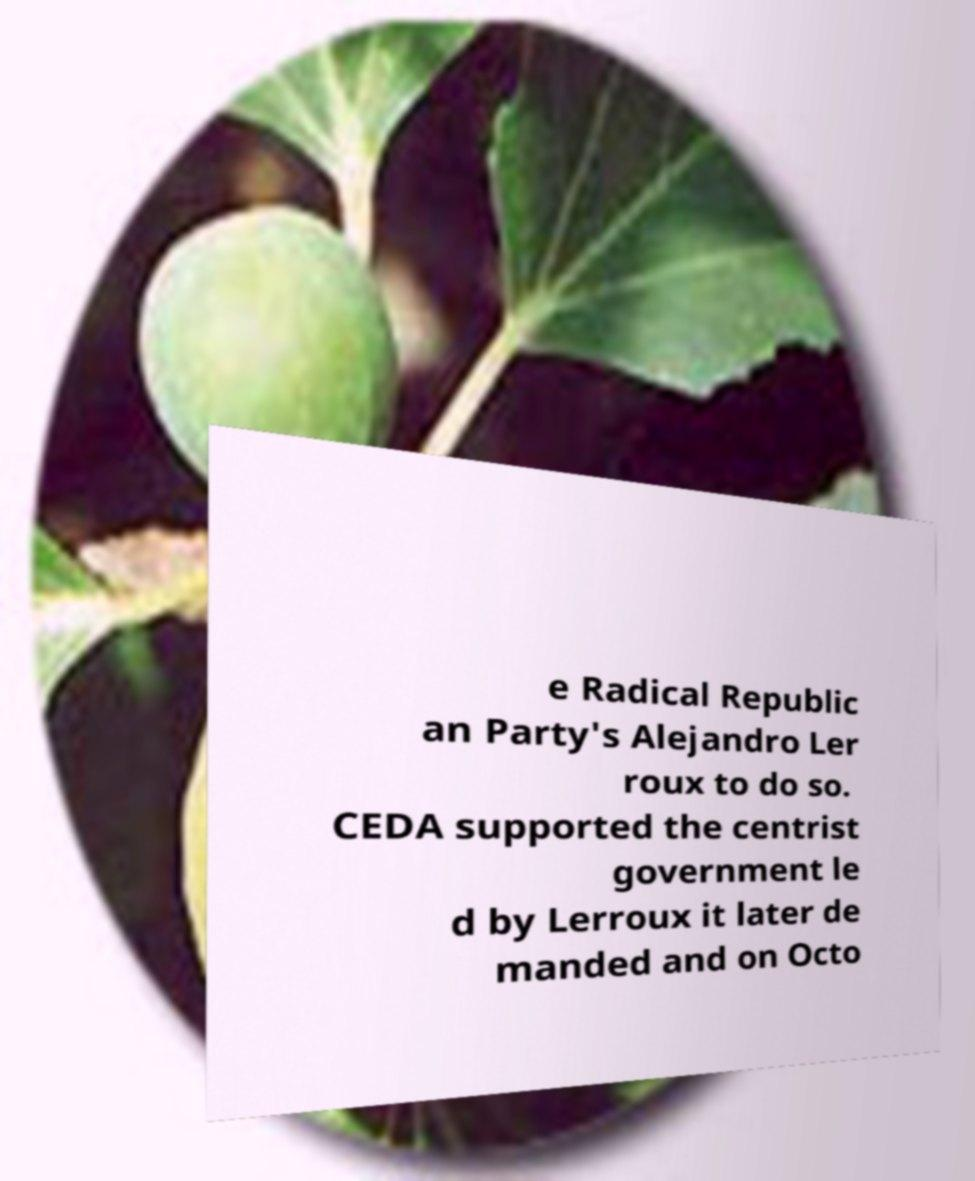Please identify and transcribe the text found in this image. e Radical Republic an Party's Alejandro Ler roux to do so. CEDA supported the centrist government le d by Lerroux it later de manded and on Octo 